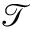Convert formula to latex. <formula><loc_0><loc_0><loc_500><loc_500>\mathcal { T }</formula> 